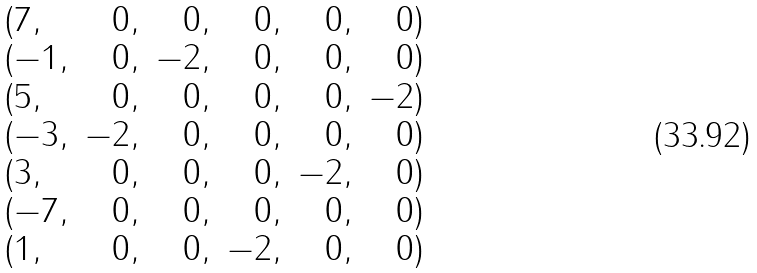Convert formula to latex. <formula><loc_0><loc_0><loc_500><loc_500>\begin{array} { l r r r r r } ( 7 , & 0 , & 0 , & 0 , & 0 , & 0 ) \\ ( - 1 , & 0 , & - 2 , & 0 , & 0 , & 0 ) \\ ( 5 , & 0 , & 0 , & 0 , & 0 , & - 2 ) \\ ( - 3 , & - 2 , & 0 , & 0 , & 0 , & 0 ) \\ ( 3 , & 0 , & 0 , & 0 , & - 2 , & 0 ) \\ ( - 7 , & 0 , & 0 , & 0 , & 0 , & 0 ) \\ ( 1 , & 0 , & 0 , & - 2 , & 0 , & 0 ) \\ \end{array}</formula> 